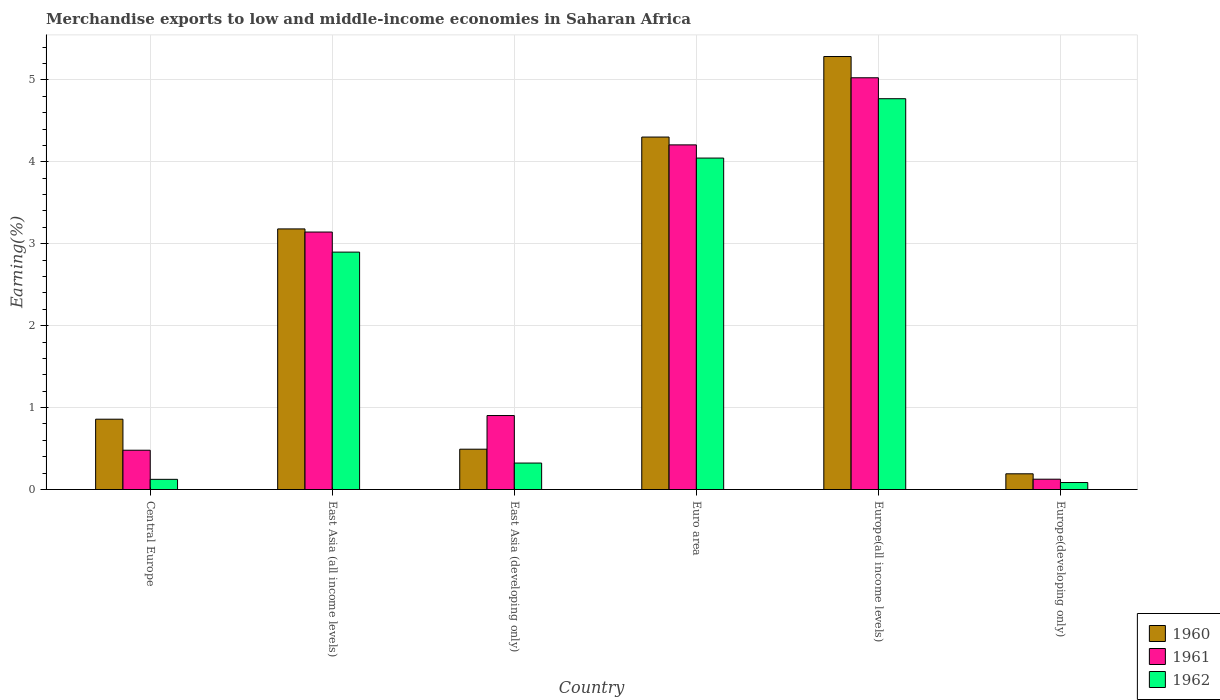How many different coloured bars are there?
Ensure brevity in your answer.  3. How many groups of bars are there?
Ensure brevity in your answer.  6. How many bars are there on the 5th tick from the right?
Give a very brief answer. 3. What is the label of the 3rd group of bars from the left?
Give a very brief answer. East Asia (developing only). What is the percentage of amount earned from merchandise exports in 1961 in Euro area?
Provide a succinct answer. 4.21. Across all countries, what is the maximum percentage of amount earned from merchandise exports in 1962?
Offer a very short reply. 4.77. Across all countries, what is the minimum percentage of amount earned from merchandise exports in 1960?
Your answer should be compact. 0.19. In which country was the percentage of amount earned from merchandise exports in 1961 maximum?
Ensure brevity in your answer.  Europe(all income levels). In which country was the percentage of amount earned from merchandise exports in 1961 minimum?
Your response must be concise. Europe(developing only). What is the total percentage of amount earned from merchandise exports in 1961 in the graph?
Make the answer very short. 13.88. What is the difference between the percentage of amount earned from merchandise exports in 1962 in Central Europe and that in East Asia (all income levels)?
Your response must be concise. -2.77. What is the difference between the percentage of amount earned from merchandise exports in 1960 in Euro area and the percentage of amount earned from merchandise exports in 1962 in Europe(developing only)?
Keep it short and to the point. 4.22. What is the average percentage of amount earned from merchandise exports in 1961 per country?
Give a very brief answer. 2.31. What is the difference between the percentage of amount earned from merchandise exports of/in 1961 and percentage of amount earned from merchandise exports of/in 1962 in East Asia (all income levels)?
Your answer should be compact. 0.25. In how many countries, is the percentage of amount earned from merchandise exports in 1962 greater than 2.2 %?
Provide a succinct answer. 3. What is the ratio of the percentage of amount earned from merchandise exports in 1962 in East Asia (developing only) to that in Euro area?
Your answer should be very brief. 0.08. Is the difference between the percentage of amount earned from merchandise exports in 1961 in Europe(all income levels) and Europe(developing only) greater than the difference between the percentage of amount earned from merchandise exports in 1962 in Europe(all income levels) and Europe(developing only)?
Your answer should be very brief. Yes. What is the difference between the highest and the second highest percentage of amount earned from merchandise exports in 1961?
Make the answer very short. -1.06. What is the difference between the highest and the lowest percentage of amount earned from merchandise exports in 1962?
Make the answer very short. 4.68. Is the sum of the percentage of amount earned from merchandise exports in 1961 in East Asia (all income levels) and Europe(all income levels) greater than the maximum percentage of amount earned from merchandise exports in 1960 across all countries?
Your answer should be very brief. Yes. What does the 2nd bar from the right in Europe(developing only) represents?
Your answer should be very brief. 1961. Is it the case that in every country, the sum of the percentage of amount earned from merchandise exports in 1962 and percentage of amount earned from merchandise exports in 1960 is greater than the percentage of amount earned from merchandise exports in 1961?
Ensure brevity in your answer.  No. Are all the bars in the graph horizontal?
Your answer should be very brief. No. Are the values on the major ticks of Y-axis written in scientific E-notation?
Keep it short and to the point. No. Does the graph contain grids?
Offer a very short reply. Yes. How many legend labels are there?
Offer a terse response. 3. How are the legend labels stacked?
Make the answer very short. Vertical. What is the title of the graph?
Your answer should be compact. Merchandise exports to low and middle-income economies in Saharan Africa. What is the label or title of the X-axis?
Make the answer very short. Country. What is the label or title of the Y-axis?
Offer a terse response. Earning(%). What is the Earning(%) in 1960 in Central Europe?
Keep it short and to the point. 0.86. What is the Earning(%) of 1961 in Central Europe?
Keep it short and to the point. 0.48. What is the Earning(%) of 1962 in Central Europe?
Ensure brevity in your answer.  0.12. What is the Earning(%) in 1960 in East Asia (all income levels)?
Keep it short and to the point. 3.18. What is the Earning(%) of 1961 in East Asia (all income levels)?
Your response must be concise. 3.14. What is the Earning(%) of 1962 in East Asia (all income levels)?
Give a very brief answer. 2.9. What is the Earning(%) of 1960 in East Asia (developing only)?
Ensure brevity in your answer.  0.49. What is the Earning(%) in 1961 in East Asia (developing only)?
Your answer should be compact. 0.9. What is the Earning(%) in 1962 in East Asia (developing only)?
Your answer should be compact. 0.32. What is the Earning(%) in 1960 in Euro area?
Make the answer very short. 4.3. What is the Earning(%) in 1961 in Euro area?
Your answer should be compact. 4.21. What is the Earning(%) in 1962 in Euro area?
Your response must be concise. 4.05. What is the Earning(%) of 1960 in Europe(all income levels)?
Make the answer very short. 5.29. What is the Earning(%) in 1961 in Europe(all income levels)?
Keep it short and to the point. 5.03. What is the Earning(%) of 1962 in Europe(all income levels)?
Ensure brevity in your answer.  4.77. What is the Earning(%) in 1960 in Europe(developing only)?
Your answer should be compact. 0.19. What is the Earning(%) of 1961 in Europe(developing only)?
Your response must be concise. 0.13. What is the Earning(%) of 1962 in Europe(developing only)?
Your answer should be compact. 0.09. Across all countries, what is the maximum Earning(%) in 1960?
Provide a short and direct response. 5.29. Across all countries, what is the maximum Earning(%) of 1961?
Provide a succinct answer. 5.03. Across all countries, what is the maximum Earning(%) of 1962?
Make the answer very short. 4.77. Across all countries, what is the minimum Earning(%) in 1960?
Keep it short and to the point. 0.19. Across all countries, what is the minimum Earning(%) in 1961?
Keep it short and to the point. 0.13. Across all countries, what is the minimum Earning(%) of 1962?
Make the answer very short. 0.09. What is the total Earning(%) of 1960 in the graph?
Keep it short and to the point. 14.31. What is the total Earning(%) in 1961 in the graph?
Provide a succinct answer. 13.88. What is the total Earning(%) of 1962 in the graph?
Provide a short and direct response. 12.25. What is the difference between the Earning(%) of 1960 in Central Europe and that in East Asia (all income levels)?
Make the answer very short. -2.32. What is the difference between the Earning(%) in 1961 in Central Europe and that in East Asia (all income levels)?
Your answer should be compact. -2.66. What is the difference between the Earning(%) of 1962 in Central Europe and that in East Asia (all income levels)?
Keep it short and to the point. -2.77. What is the difference between the Earning(%) of 1960 in Central Europe and that in East Asia (developing only)?
Give a very brief answer. 0.37. What is the difference between the Earning(%) in 1961 in Central Europe and that in East Asia (developing only)?
Make the answer very short. -0.42. What is the difference between the Earning(%) of 1962 in Central Europe and that in East Asia (developing only)?
Your answer should be very brief. -0.2. What is the difference between the Earning(%) in 1960 in Central Europe and that in Euro area?
Your answer should be very brief. -3.44. What is the difference between the Earning(%) of 1961 in Central Europe and that in Euro area?
Ensure brevity in your answer.  -3.73. What is the difference between the Earning(%) of 1962 in Central Europe and that in Euro area?
Keep it short and to the point. -3.92. What is the difference between the Earning(%) in 1960 in Central Europe and that in Europe(all income levels)?
Keep it short and to the point. -4.43. What is the difference between the Earning(%) of 1961 in Central Europe and that in Europe(all income levels)?
Keep it short and to the point. -4.55. What is the difference between the Earning(%) in 1962 in Central Europe and that in Europe(all income levels)?
Make the answer very short. -4.65. What is the difference between the Earning(%) of 1960 in Central Europe and that in Europe(developing only)?
Give a very brief answer. 0.67. What is the difference between the Earning(%) of 1961 in Central Europe and that in Europe(developing only)?
Your answer should be very brief. 0.35. What is the difference between the Earning(%) in 1962 in Central Europe and that in Europe(developing only)?
Your answer should be very brief. 0.04. What is the difference between the Earning(%) in 1960 in East Asia (all income levels) and that in East Asia (developing only)?
Offer a terse response. 2.69. What is the difference between the Earning(%) of 1961 in East Asia (all income levels) and that in East Asia (developing only)?
Keep it short and to the point. 2.24. What is the difference between the Earning(%) in 1962 in East Asia (all income levels) and that in East Asia (developing only)?
Offer a very short reply. 2.57. What is the difference between the Earning(%) in 1960 in East Asia (all income levels) and that in Euro area?
Make the answer very short. -1.12. What is the difference between the Earning(%) in 1961 in East Asia (all income levels) and that in Euro area?
Your answer should be very brief. -1.06. What is the difference between the Earning(%) in 1962 in East Asia (all income levels) and that in Euro area?
Give a very brief answer. -1.15. What is the difference between the Earning(%) in 1960 in East Asia (all income levels) and that in Europe(all income levels)?
Your response must be concise. -2.1. What is the difference between the Earning(%) of 1961 in East Asia (all income levels) and that in Europe(all income levels)?
Provide a succinct answer. -1.88. What is the difference between the Earning(%) in 1962 in East Asia (all income levels) and that in Europe(all income levels)?
Your answer should be compact. -1.87. What is the difference between the Earning(%) in 1960 in East Asia (all income levels) and that in Europe(developing only)?
Keep it short and to the point. 2.99. What is the difference between the Earning(%) of 1961 in East Asia (all income levels) and that in Europe(developing only)?
Ensure brevity in your answer.  3.02. What is the difference between the Earning(%) in 1962 in East Asia (all income levels) and that in Europe(developing only)?
Your answer should be compact. 2.81. What is the difference between the Earning(%) of 1960 in East Asia (developing only) and that in Euro area?
Your answer should be compact. -3.81. What is the difference between the Earning(%) in 1961 in East Asia (developing only) and that in Euro area?
Give a very brief answer. -3.3. What is the difference between the Earning(%) of 1962 in East Asia (developing only) and that in Euro area?
Provide a short and direct response. -3.72. What is the difference between the Earning(%) in 1960 in East Asia (developing only) and that in Europe(all income levels)?
Make the answer very short. -4.79. What is the difference between the Earning(%) in 1961 in East Asia (developing only) and that in Europe(all income levels)?
Offer a terse response. -4.12. What is the difference between the Earning(%) of 1962 in East Asia (developing only) and that in Europe(all income levels)?
Offer a very short reply. -4.45. What is the difference between the Earning(%) in 1960 in East Asia (developing only) and that in Europe(developing only)?
Provide a succinct answer. 0.3. What is the difference between the Earning(%) in 1961 in East Asia (developing only) and that in Europe(developing only)?
Ensure brevity in your answer.  0.78. What is the difference between the Earning(%) of 1962 in East Asia (developing only) and that in Europe(developing only)?
Give a very brief answer. 0.24. What is the difference between the Earning(%) of 1960 in Euro area and that in Europe(all income levels)?
Give a very brief answer. -0.98. What is the difference between the Earning(%) of 1961 in Euro area and that in Europe(all income levels)?
Your answer should be very brief. -0.82. What is the difference between the Earning(%) of 1962 in Euro area and that in Europe(all income levels)?
Give a very brief answer. -0.72. What is the difference between the Earning(%) in 1960 in Euro area and that in Europe(developing only)?
Keep it short and to the point. 4.11. What is the difference between the Earning(%) in 1961 in Euro area and that in Europe(developing only)?
Ensure brevity in your answer.  4.08. What is the difference between the Earning(%) of 1962 in Euro area and that in Europe(developing only)?
Provide a short and direct response. 3.96. What is the difference between the Earning(%) of 1960 in Europe(all income levels) and that in Europe(developing only)?
Make the answer very short. 5.09. What is the difference between the Earning(%) of 1961 in Europe(all income levels) and that in Europe(developing only)?
Your answer should be very brief. 4.9. What is the difference between the Earning(%) in 1962 in Europe(all income levels) and that in Europe(developing only)?
Your answer should be compact. 4.68. What is the difference between the Earning(%) in 1960 in Central Europe and the Earning(%) in 1961 in East Asia (all income levels)?
Offer a very short reply. -2.28. What is the difference between the Earning(%) in 1960 in Central Europe and the Earning(%) in 1962 in East Asia (all income levels)?
Make the answer very short. -2.04. What is the difference between the Earning(%) of 1961 in Central Europe and the Earning(%) of 1962 in East Asia (all income levels)?
Offer a very short reply. -2.42. What is the difference between the Earning(%) of 1960 in Central Europe and the Earning(%) of 1961 in East Asia (developing only)?
Keep it short and to the point. -0.04. What is the difference between the Earning(%) of 1960 in Central Europe and the Earning(%) of 1962 in East Asia (developing only)?
Offer a terse response. 0.54. What is the difference between the Earning(%) of 1961 in Central Europe and the Earning(%) of 1962 in East Asia (developing only)?
Keep it short and to the point. 0.16. What is the difference between the Earning(%) in 1960 in Central Europe and the Earning(%) in 1961 in Euro area?
Your response must be concise. -3.35. What is the difference between the Earning(%) of 1960 in Central Europe and the Earning(%) of 1962 in Euro area?
Your response must be concise. -3.19. What is the difference between the Earning(%) of 1961 in Central Europe and the Earning(%) of 1962 in Euro area?
Give a very brief answer. -3.57. What is the difference between the Earning(%) of 1960 in Central Europe and the Earning(%) of 1961 in Europe(all income levels)?
Offer a terse response. -4.17. What is the difference between the Earning(%) in 1960 in Central Europe and the Earning(%) in 1962 in Europe(all income levels)?
Your answer should be very brief. -3.91. What is the difference between the Earning(%) of 1961 in Central Europe and the Earning(%) of 1962 in Europe(all income levels)?
Offer a terse response. -4.29. What is the difference between the Earning(%) in 1960 in Central Europe and the Earning(%) in 1961 in Europe(developing only)?
Offer a terse response. 0.73. What is the difference between the Earning(%) of 1960 in Central Europe and the Earning(%) of 1962 in Europe(developing only)?
Offer a very short reply. 0.77. What is the difference between the Earning(%) in 1961 in Central Europe and the Earning(%) in 1962 in Europe(developing only)?
Keep it short and to the point. 0.39. What is the difference between the Earning(%) in 1960 in East Asia (all income levels) and the Earning(%) in 1961 in East Asia (developing only)?
Provide a short and direct response. 2.28. What is the difference between the Earning(%) of 1960 in East Asia (all income levels) and the Earning(%) of 1962 in East Asia (developing only)?
Offer a terse response. 2.86. What is the difference between the Earning(%) in 1961 in East Asia (all income levels) and the Earning(%) in 1962 in East Asia (developing only)?
Your answer should be compact. 2.82. What is the difference between the Earning(%) of 1960 in East Asia (all income levels) and the Earning(%) of 1961 in Euro area?
Your answer should be compact. -1.03. What is the difference between the Earning(%) of 1960 in East Asia (all income levels) and the Earning(%) of 1962 in Euro area?
Your answer should be very brief. -0.86. What is the difference between the Earning(%) of 1961 in East Asia (all income levels) and the Earning(%) of 1962 in Euro area?
Your answer should be very brief. -0.9. What is the difference between the Earning(%) in 1960 in East Asia (all income levels) and the Earning(%) in 1961 in Europe(all income levels)?
Offer a very short reply. -1.84. What is the difference between the Earning(%) in 1960 in East Asia (all income levels) and the Earning(%) in 1962 in Europe(all income levels)?
Give a very brief answer. -1.59. What is the difference between the Earning(%) of 1961 in East Asia (all income levels) and the Earning(%) of 1962 in Europe(all income levels)?
Ensure brevity in your answer.  -1.63. What is the difference between the Earning(%) in 1960 in East Asia (all income levels) and the Earning(%) in 1961 in Europe(developing only)?
Your answer should be very brief. 3.06. What is the difference between the Earning(%) of 1960 in East Asia (all income levels) and the Earning(%) of 1962 in Europe(developing only)?
Provide a succinct answer. 3.1. What is the difference between the Earning(%) of 1961 in East Asia (all income levels) and the Earning(%) of 1962 in Europe(developing only)?
Make the answer very short. 3.06. What is the difference between the Earning(%) of 1960 in East Asia (developing only) and the Earning(%) of 1961 in Euro area?
Provide a short and direct response. -3.71. What is the difference between the Earning(%) of 1960 in East Asia (developing only) and the Earning(%) of 1962 in Euro area?
Your answer should be very brief. -3.55. What is the difference between the Earning(%) in 1961 in East Asia (developing only) and the Earning(%) in 1962 in Euro area?
Your answer should be compact. -3.14. What is the difference between the Earning(%) of 1960 in East Asia (developing only) and the Earning(%) of 1961 in Europe(all income levels)?
Provide a succinct answer. -4.53. What is the difference between the Earning(%) in 1960 in East Asia (developing only) and the Earning(%) in 1962 in Europe(all income levels)?
Provide a short and direct response. -4.28. What is the difference between the Earning(%) in 1961 in East Asia (developing only) and the Earning(%) in 1962 in Europe(all income levels)?
Provide a succinct answer. -3.87. What is the difference between the Earning(%) in 1960 in East Asia (developing only) and the Earning(%) in 1961 in Europe(developing only)?
Keep it short and to the point. 0.37. What is the difference between the Earning(%) in 1960 in East Asia (developing only) and the Earning(%) in 1962 in Europe(developing only)?
Offer a terse response. 0.41. What is the difference between the Earning(%) in 1961 in East Asia (developing only) and the Earning(%) in 1962 in Europe(developing only)?
Your response must be concise. 0.82. What is the difference between the Earning(%) of 1960 in Euro area and the Earning(%) of 1961 in Europe(all income levels)?
Make the answer very short. -0.72. What is the difference between the Earning(%) of 1960 in Euro area and the Earning(%) of 1962 in Europe(all income levels)?
Provide a succinct answer. -0.47. What is the difference between the Earning(%) of 1961 in Euro area and the Earning(%) of 1962 in Europe(all income levels)?
Ensure brevity in your answer.  -0.56. What is the difference between the Earning(%) in 1960 in Euro area and the Earning(%) in 1961 in Europe(developing only)?
Keep it short and to the point. 4.18. What is the difference between the Earning(%) of 1960 in Euro area and the Earning(%) of 1962 in Europe(developing only)?
Your answer should be compact. 4.22. What is the difference between the Earning(%) in 1961 in Euro area and the Earning(%) in 1962 in Europe(developing only)?
Offer a terse response. 4.12. What is the difference between the Earning(%) of 1960 in Europe(all income levels) and the Earning(%) of 1961 in Europe(developing only)?
Provide a succinct answer. 5.16. What is the difference between the Earning(%) in 1960 in Europe(all income levels) and the Earning(%) in 1962 in Europe(developing only)?
Give a very brief answer. 5.2. What is the difference between the Earning(%) in 1961 in Europe(all income levels) and the Earning(%) in 1962 in Europe(developing only)?
Your response must be concise. 4.94. What is the average Earning(%) of 1960 per country?
Provide a succinct answer. 2.39. What is the average Earning(%) of 1961 per country?
Your response must be concise. 2.31. What is the average Earning(%) in 1962 per country?
Offer a terse response. 2.04. What is the difference between the Earning(%) in 1960 and Earning(%) in 1961 in Central Europe?
Make the answer very short. 0.38. What is the difference between the Earning(%) of 1960 and Earning(%) of 1962 in Central Europe?
Offer a very short reply. 0.73. What is the difference between the Earning(%) in 1961 and Earning(%) in 1962 in Central Europe?
Your answer should be compact. 0.36. What is the difference between the Earning(%) in 1960 and Earning(%) in 1961 in East Asia (all income levels)?
Offer a very short reply. 0.04. What is the difference between the Earning(%) of 1960 and Earning(%) of 1962 in East Asia (all income levels)?
Give a very brief answer. 0.28. What is the difference between the Earning(%) of 1961 and Earning(%) of 1962 in East Asia (all income levels)?
Your answer should be very brief. 0.25. What is the difference between the Earning(%) of 1960 and Earning(%) of 1961 in East Asia (developing only)?
Your answer should be very brief. -0.41. What is the difference between the Earning(%) of 1960 and Earning(%) of 1962 in East Asia (developing only)?
Provide a short and direct response. 0.17. What is the difference between the Earning(%) of 1961 and Earning(%) of 1962 in East Asia (developing only)?
Make the answer very short. 0.58. What is the difference between the Earning(%) in 1960 and Earning(%) in 1961 in Euro area?
Offer a terse response. 0.1. What is the difference between the Earning(%) in 1960 and Earning(%) in 1962 in Euro area?
Your response must be concise. 0.26. What is the difference between the Earning(%) in 1961 and Earning(%) in 1962 in Euro area?
Offer a terse response. 0.16. What is the difference between the Earning(%) of 1960 and Earning(%) of 1961 in Europe(all income levels)?
Your response must be concise. 0.26. What is the difference between the Earning(%) of 1960 and Earning(%) of 1962 in Europe(all income levels)?
Keep it short and to the point. 0.52. What is the difference between the Earning(%) in 1961 and Earning(%) in 1962 in Europe(all income levels)?
Your answer should be compact. 0.26. What is the difference between the Earning(%) of 1960 and Earning(%) of 1961 in Europe(developing only)?
Offer a very short reply. 0.07. What is the difference between the Earning(%) in 1960 and Earning(%) in 1962 in Europe(developing only)?
Offer a very short reply. 0.11. What is the difference between the Earning(%) in 1961 and Earning(%) in 1962 in Europe(developing only)?
Provide a short and direct response. 0.04. What is the ratio of the Earning(%) of 1960 in Central Europe to that in East Asia (all income levels)?
Provide a succinct answer. 0.27. What is the ratio of the Earning(%) of 1961 in Central Europe to that in East Asia (all income levels)?
Offer a terse response. 0.15. What is the ratio of the Earning(%) in 1962 in Central Europe to that in East Asia (all income levels)?
Your answer should be very brief. 0.04. What is the ratio of the Earning(%) of 1960 in Central Europe to that in East Asia (developing only)?
Give a very brief answer. 1.74. What is the ratio of the Earning(%) of 1961 in Central Europe to that in East Asia (developing only)?
Make the answer very short. 0.53. What is the ratio of the Earning(%) of 1962 in Central Europe to that in East Asia (developing only)?
Offer a very short reply. 0.38. What is the ratio of the Earning(%) of 1960 in Central Europe to that in Euro area?
Offer a very short reply. 0.2. What is the ratio of the Earning(%) of 1961 in Central Europe to that in Euro area?
Provide a succinct answer. 0.11. What is the ratio of the Earning(%) of 1962 in Central Europe to that in Euro area?
Your answer should be very brief. 0.03. What is the ratio of the Earning(%) of 1960 in Central Europe to that in Europe(all income levels)?
Your answer should be very brief. 0.16. What is the ratio of the Earning(%) of 1961 in Central Europe to that in Europe(all income levels)?
Provide a succinct answer. 0.1. What is the ratio of the Earning(%) of 1962 in Central Europe to that in Europe(all income levels)?
Provide a short and direct response. 0.03. What is the ratio of the Earning(%) of 1960 in Central Europe to that in Europe(developing only)?
Ensure brevity in your answer.  4.47. What is the ratio of the Earning(%) of 1961 in Central Europe to that in Europe(developing only)?
Your answer should be compact. 3.81. What is the ratio of the Earning(%) in 1962 in Central Europe to that in Europe(developing only)?
Your answer should be compact. 1.45. What is the ratio of the Earning(%) in 1960 in East Asia (all income levels) to that in East Asia (developing only)?
Your answer should be compact. 6.46. What is the ratio of the Earning(%) of 1961 in East Asia (all income levels) to that in East Asia (developing only)?
Your answer should be very brief. 3.48. What is the ratio of the Earning(%) of 1962 in East Asia (all income levels) to that in East Asia (developing only)?
Your answer should be very brief. 8.97. What is the ratio of the Earning(%) of 1960 in East Asia (all income levels) to that in Euro area?
Your answer should be compact. 0.74. What is the ratio of the Earning(%) in 1961 in East Asia (all income levels) to that in Euro area?
Provide a succinct answer. 0.75. What is the ratio of the Earning(%) of 1962 in East Asia (all income levels) to that in Euro area?
Provide a succinct answer. 0.72. What is the ratio of the Earning(%) of 1960 in East Asia (all income levels) to that in Europe(all income levels)?
Offer a terse response. 0.6. What is the ratio of the Earning(%) of 1961 in East Asia (all income levels) to that in Europe(all income levels)?
Give a very brief answer. 0.63. What is the ratio of the Earning(%) of 1962 in East Asia (all income levels) to that in Europe(all income levels)?
Provide a short and direct response. 0.61. What is the ratio of the Earning(%) of 1960 in East Asia (all income levels) to that in Europe(developing only)?
Provide a short and direct response. 16.58. What is the ratio of the Earning(%) in 1961 in East Asia (all income levels) to that in Europe(developing only)?
Give a very brief answer. 24.95. What is the ratio of the Earning(%) of 1962 in East Asia (all income levels) to that in Europe(developing only)?
Keep it short and to the point. 33.92. What is the ratio of the Earning(%) in 1960 in East Asia (developing only) to that in Euro area?
Offer a terse response. 0.11. What is the ratio of the Earning(%) in 1961 in East Asia (developing only) to that in Euro area?
Your answer should be compact. 0.21. What is the ratio of the Earning(%) of 1962 in East Asia (developing only) to that in Euro area?
Your answer should be very brief. 0.08. What is the ratio of the Earning(%) in 1960 in East Asia (developing only) to that in Europe(all income levels)?
Your answer should be compact. 0.09. What is the ratio of the Earning(%) of 1961 in East Asia (developing only) to that in Europe(all income levels)?
Keep it short and to the point. 0.18. What is the ratio of the Earning(%) in 1962 in East Asia (developing only) to that in Europe(all income levels)?
Your response must be concise. 0.07. What is the ratio of the Earning(%) in 1960 in East Asia (developing only) to that in Europe(developing only)?
Keep it short and to the point. 2.56. What is the ratio of the Earning(%) of 1961 in East Asia (developing only) to that in Europe(developing only)?
Provide a short and direct response. 7.17. What is the ratio of the Earning(%) of 1962 in East Asia (developing only) to that in Europe(developing only)?
Offer a very short reply. 3.78. What is the ratio of the Earning(%) in 1960 in Euro area to that in Europe(all income levels)?
Provide a succinct answer. 0.81. What is the ratio of the Earning(%) of 1961 in Euro area to that in Europe(all income levels)?
Offer a terse response. 0.84. What is the ratio of the Earning(%) of 1962 in Euro area to that in Europe(all income levels)?
Your answer should be compact. 0.85. What is the ratio of the Earning(%) of 1960 in Euro area to that in Europe(developing only)?
Ensure brevity in your answer.  22.42. What is the ratio of the Earning(%) in 1961 in Euro area to that in Europe(developing only)?
Your answer should be compact. 33.4. What is the ratio of the Earning(%) in 1962 in Euro area to that in Europe(developing only)?
Keep it short and to the point. 47.36. What is the ratio of the Earning(%) of 1960 in Europe(all income levels) to that in Europe(developing only)?
Your answer should be compact. 27.54. What is the ratio of the Earning(%) in 1961 in Europe(all income levels) to that in Europe(developing only)?
Provide a short and direct response. 39.9. What is the ratio of the Earning(%) in 1962 in Europe(all income levels) to that in Europe(developing only)?
Give a very brief answer. 55.85. What is the difference between the highest and the second highest Earning(%) in 1960?
Ensure brevity in your answer.  0.98. What is the difference between the highest and the second highest Earning(%) of 1961?
Your answer should be compact. 0.82. What is the difference between the highest and the second highest Earning(%) of 1962?
Make the answer very short. 0.72. What is the difference between the highest and the lowest Earning(%) of 1960?
Keep it short and to the point. 5.09. What is the difference between the highest and the lowest Earning(%) of 1961?
Ensure brevity in your answer.  4.9. What is the difference between the highest and the lowest Earning(%) in 1962?
Provide a short and direct response. 4.68. 